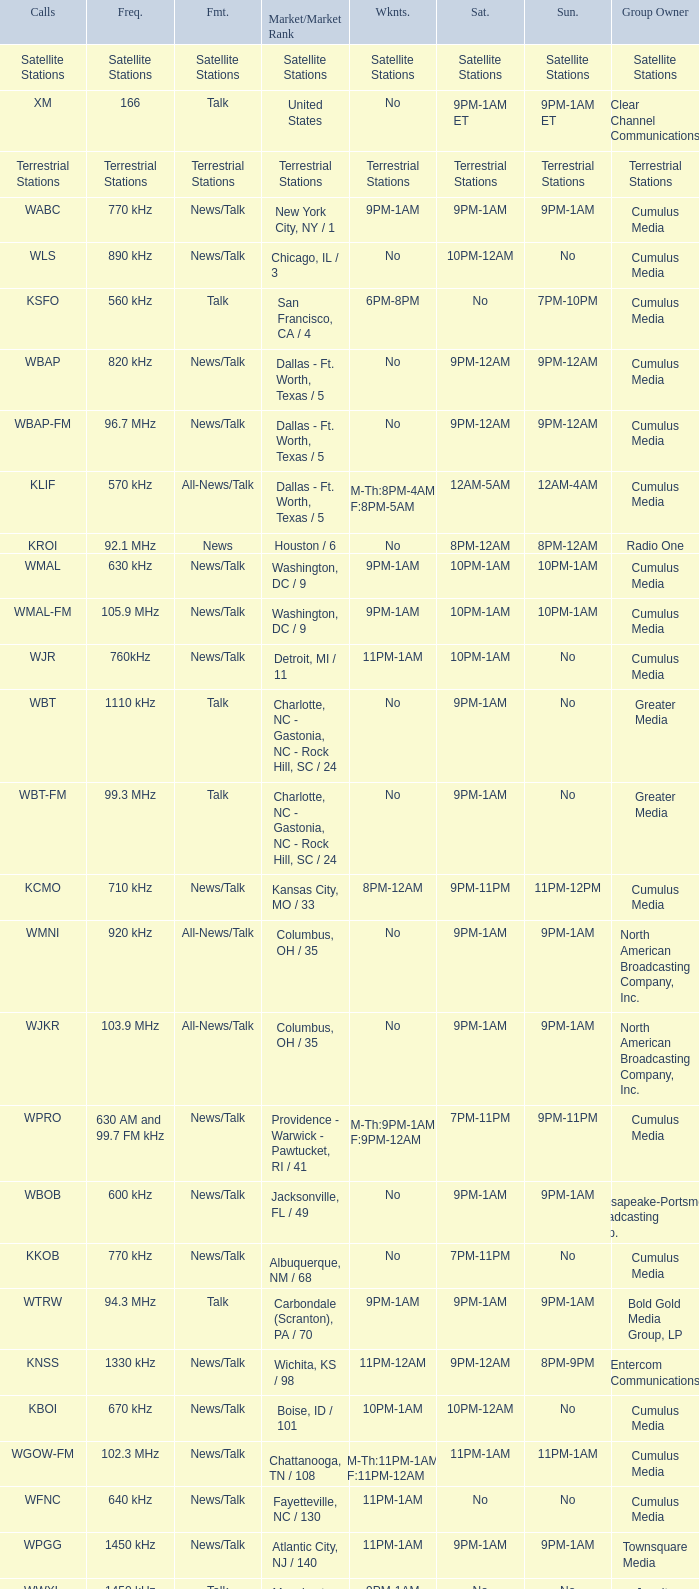What is the market for the 11pm-1am Saturday game? Chattanooga, TN / 108. 